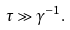<formula> <loc_0><loc_0><loc_500><loc_500>\tau \gg \gamma ^ { - 1 } .</formula> 